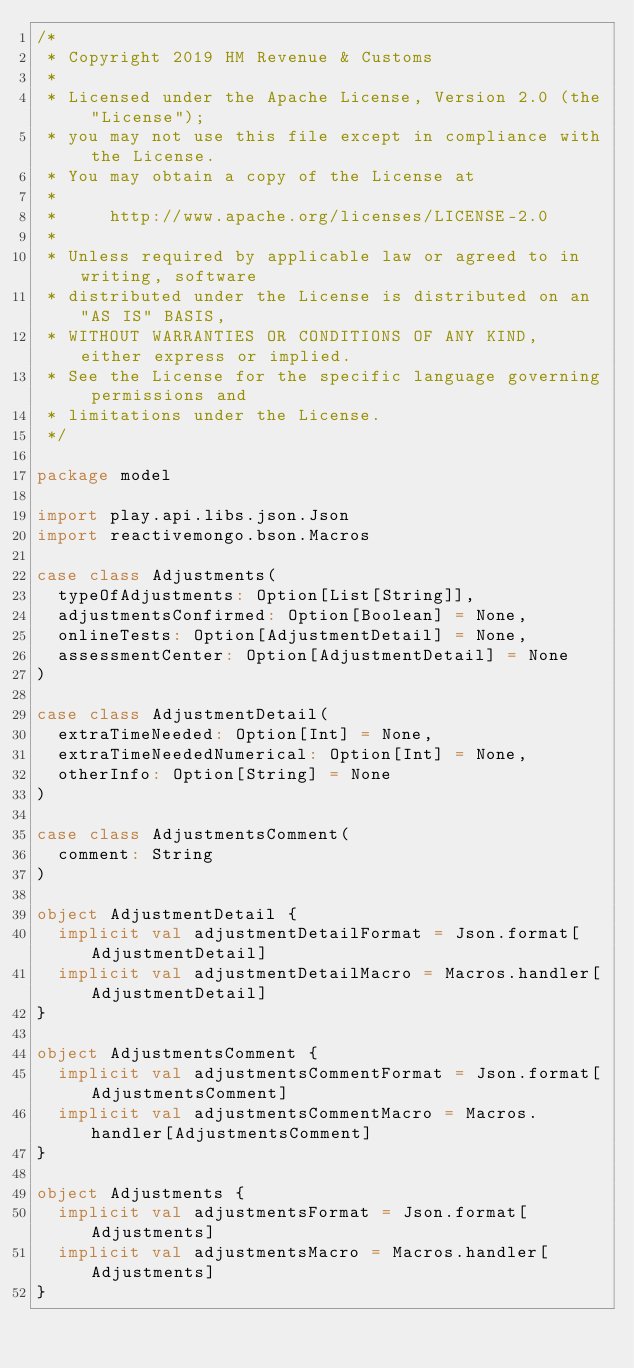Convert code to text. <code><loc_0><loc_0><loc_500><loc_500><_Scala_>/*
 * Copyright 2019 HM Revenue & Customs
 *
 * Licensed under the Apache License, Version 2.0 (the "License");
 * you may not use this file except in compliance with the License.
 * You may obtain a copy of the License at
 *
 *     http://www.apache.org/licenses/LICENSE-2.0
 *
 * Unless required by applicable law or agreed to in writing, software
 * distributed under the License is distributed on an "AS IS" BASIS,
 * WITHOUT WARRANTIES OR CONDITIONS OF ANY KIND, either express or implied.
 * See the License for the specific language governing permissions and
 * limitations under the License.
 */

package model

import play.api.libs.json.Json
import reactivemongo.bson.Macros

case class Adjustments(
  typeOfAdjustments: Option[List[String]],
  adjustmentsConfirmed: Option[Boolean] = None,
  onlineTests: Option[AdjustmentDetail] = None,
  assessmentCenter: Option[AdjustmentDetail] = None
)

case class AdjustmentDetail(
  extraTimeNeeded: Option[Int] = None,
  extraTimeNeededNumerical: Option[Int] = None,
  otherInfo: Option[String] = None
)

case class AdjustmentsComment(
  comment: String
)

object AdjustmentDetail {
  implicit val adjustmentDetailFormat = Json.format[AdjustmentDetail]
  implicit val adjustmentDetailMacro = Macros.handler[AdjustmentDetail]
}

object AdjustmentsComment {
  implicit val adjustmentsCommentFormat = Json.format[AdjustmentsComment]
  implicit val adjustmentsCommentMacro = Macros.handler[AdjustmentsComment]
}

object Adjustments {
  implicit val adjustmentsFormat = Json.format[Adjustments]
  implicit val adjustmentsMacro = Macros.handler[Adjustments]
}

</code> 